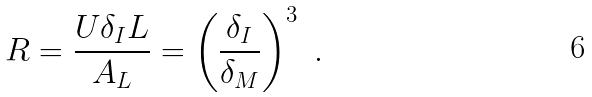Convert formula to latex. <formula><loc_0><loc_0><loc_500><loc_500>R = \frac { U \delta _ { I } L } { A _ { L } } = \left ( \frac { \delta _ { I } } { \delta _ { M } } \right ) ^ { 3 } \ .</formula> 